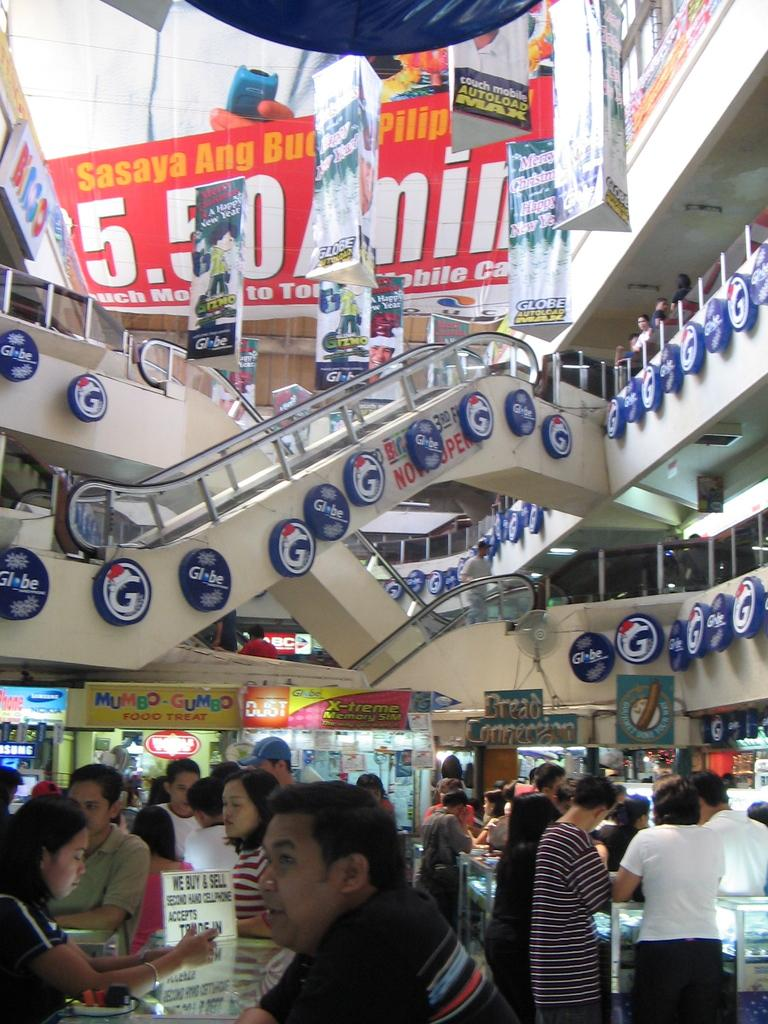What types of people are present in the image? There are men and women standing in the image. What structure can be seen in the background? There is a building in the image. What additional elements are present in the image? There are banners in the image. What type of education is being offered to the women wearing skirts in the image? There is no information about education or skirts in the image; it only shows men and women standing with banners. 